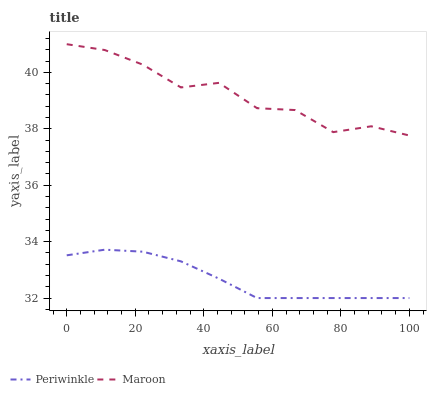Does Periwinkle have the minimum area under the curve?
Answer yes or no. Yes. Does Maroon have the maximum area under the curve?
Answer yes or no. Yes. Does Maroon have the minimum area under the curve?
Answer yes or no. No. Is Periwinkle the smoothest?
Answer yes or no. Yes. Is Maroon the roughest?
Answer yes or no. Yes. Is Maroon the smoothest?
Answer yes or no. No. Does Periwinkle have the lowest value?
Answer yes or no. Yes. Does Maroon have the lowest value?
Answer yes or no. No. Does Maroon have the highest value?
Answer yes or no. Yes. Is Periwinkle less than Maroon?
Answer yes or no. Yes. Is Maroon greater than Periwinkle?
Answer yes or no. Yes. Does Periwinkle intersect Maroon?
Answer yes or no. No. 